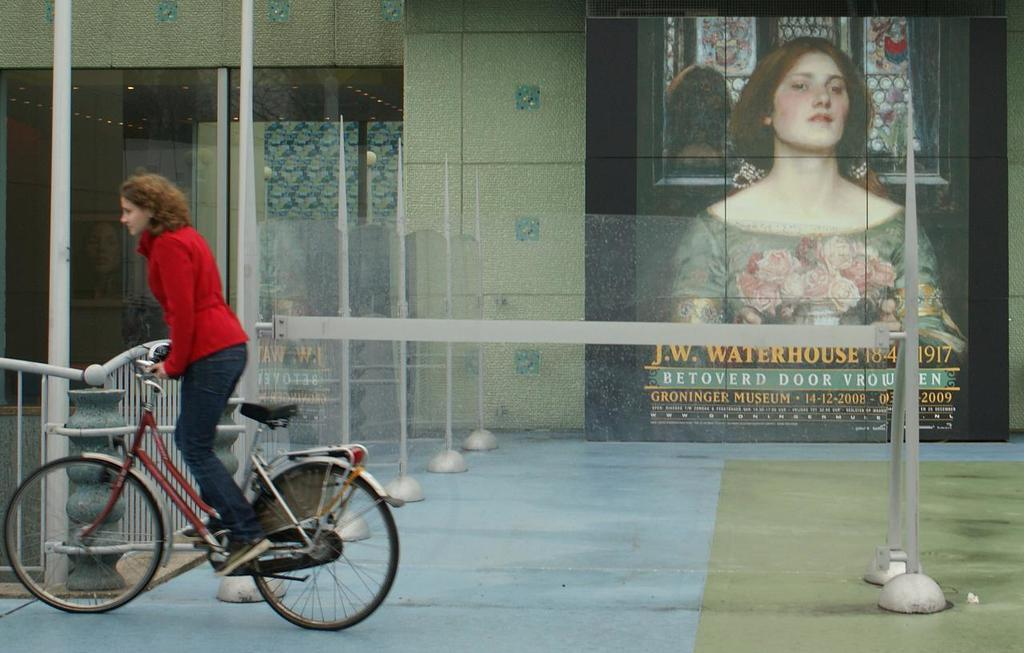Who is the main subject in the image? There is a woman in the image. What is the woman doing in the image? The woman is riding a bicycle. What can be seen in the background of the image? There is a building in the image. Are there any other images of women in the image? Yes, there is a poster of a woman present in the image. What type of ship can be seen sailing in the background of the image? There is no ship present in the image; it features a woman riding a bicycle and a building in the background. Can you tell me how many lamps are visible on the bicycle in the image? There is no lamp present on the bicycle in the image. 